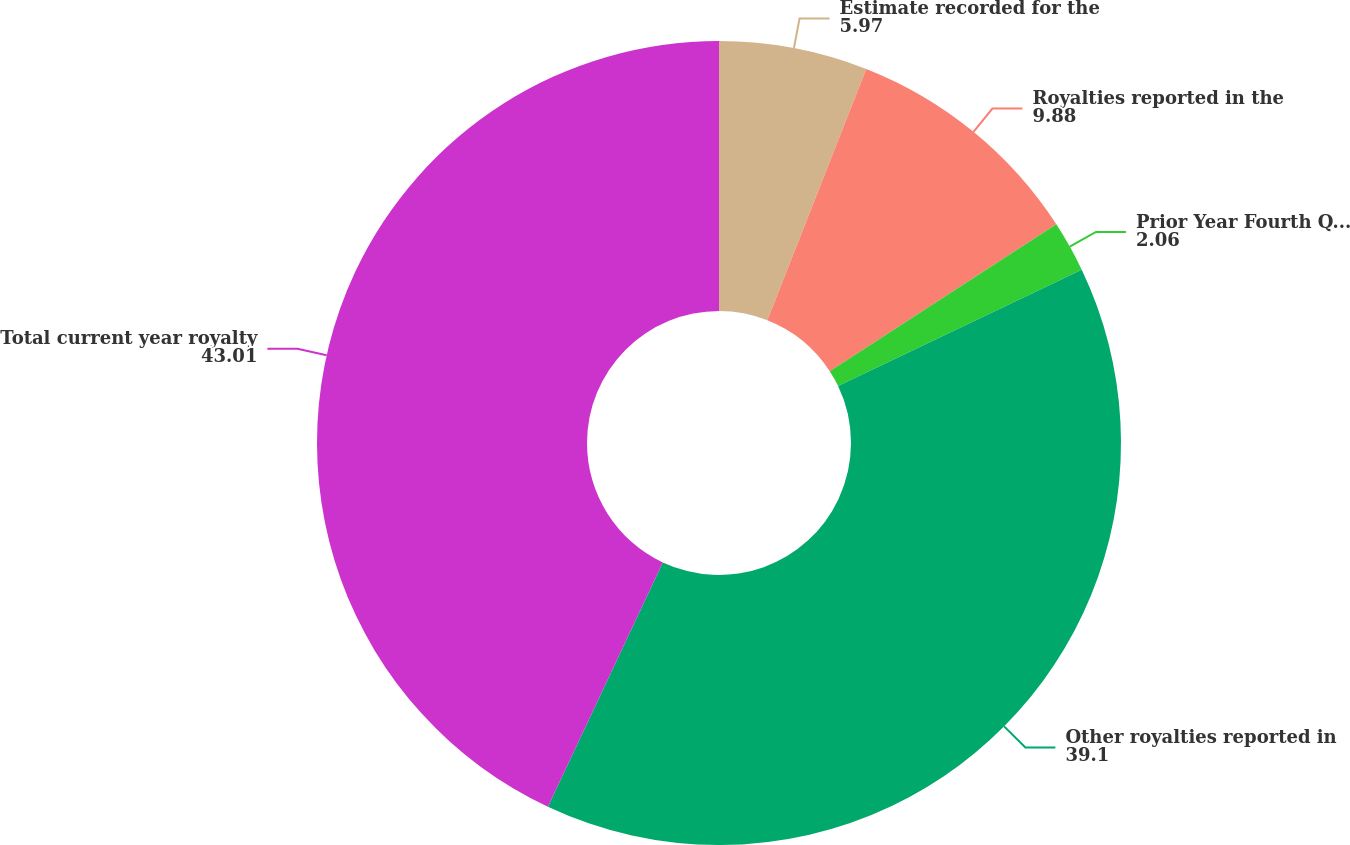Convert chart to OTSL. <chart><loc_0><loc_0><loc_500><loc_500><pie_chart><fcel>Estimate recorded for the<fcel>Royalties reported in the<fcel>Prior Year Fourth Quarter<fcel>Other royalties reported in<fcel>Total current year royalty<nl><fcel>5.97%<fcel>9.88%<fcel>2.06%<fcel>39.1%<fcel>43.01%<nl></chart> 